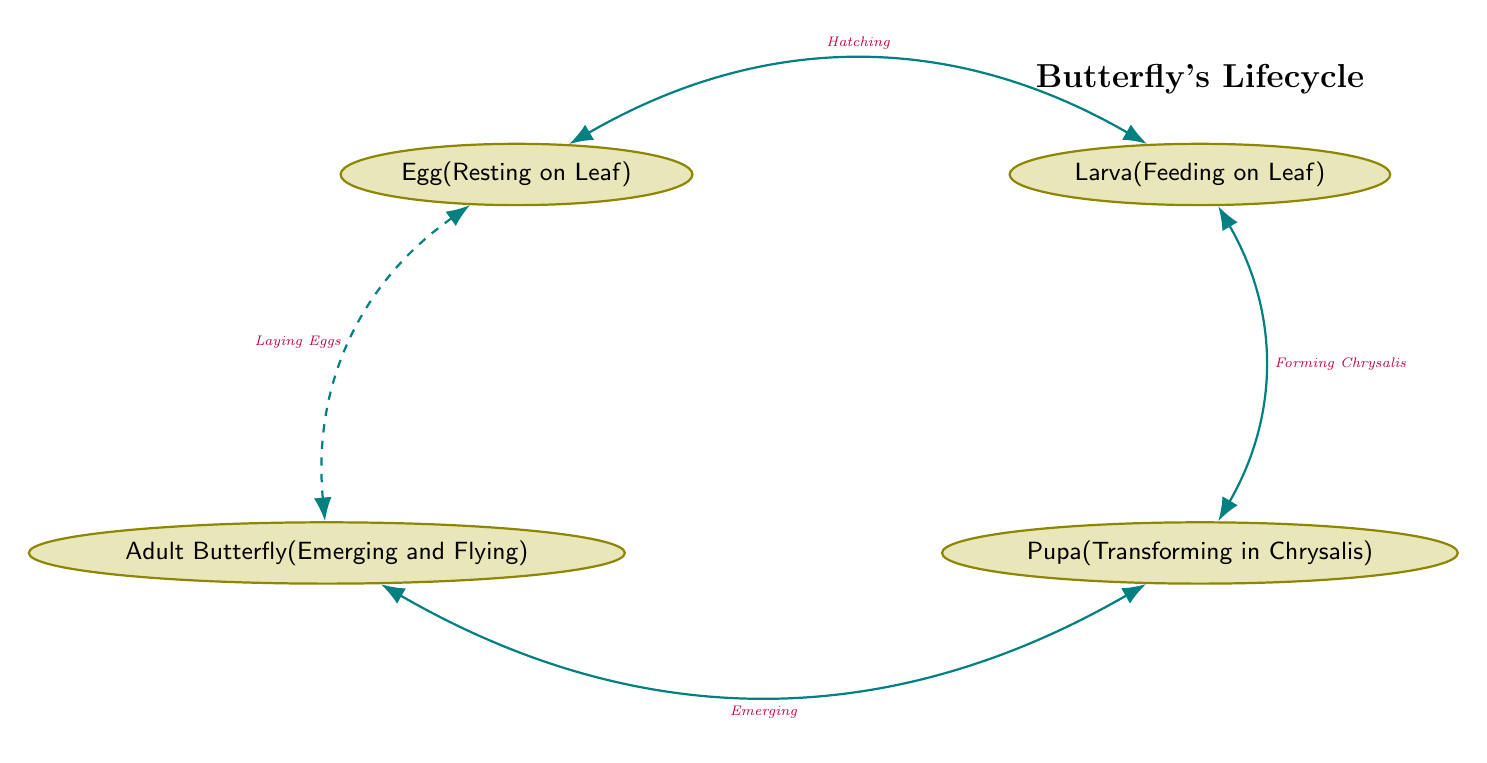What is the initial state of the butterfly's lifecycle? The diagram shows "Egg" as the first state in the lifecycle.
Answer: Egg How many states are represented in the diagram? By counting the distinct nodes labeled in the diagram, there are four states: Egg, Larva (Caterpillar), Pupa (Chrysalis), and Adult Butterfly.
Answer: 4 What behavior is associated with the "Pupa (Chrysalis)" state? The diagram specifies "Transforming in Chrysalis" as the behavior for the Pupa state.
Answer: Transforming in Chrysalis What action transitions the state from "Larva (Caterpillar)" to "Pupa (Chrysalis)"? The transition is indicated by the action labeled "Forming Chrysalis" connecting these two states.
Answer: Forming Chrysalis Which state leads to the "Adult Butterfly"? The arrow in the diagram points from "Pupa (Chrysalis)" to "Adult Butterfly," indicating that the Pupa state leads directly to the adult stage.
Answer: Pupa (Chrysalis) Describe the ultimate behavioral action of the adult butterfly. The diagram notes that the adult butterfly's behavior includes "Emerging and Flying," which defines its active lifestyle post-metamorphosis.
Answer: Emerging and Flying What is the final transition indicated in the lifecycle? The diagram describes the last transition as "Emerging," which occurs when the Pupa state transforms to the Adult Butterfly state.
Answer: Emerging What does the dashed line indicate in the diagram? The dashed line shows a transition from "Adult Butterfly" back to "Egg," indicating a cycle where the adult lays eggs, completing the lifecycle.
Answer: Laying Eggs From which state does the lifecycle start? The diagram clearly indicates that the lifecycle begins at the Egg state, as it is the first node shown.
Answer: Egg 